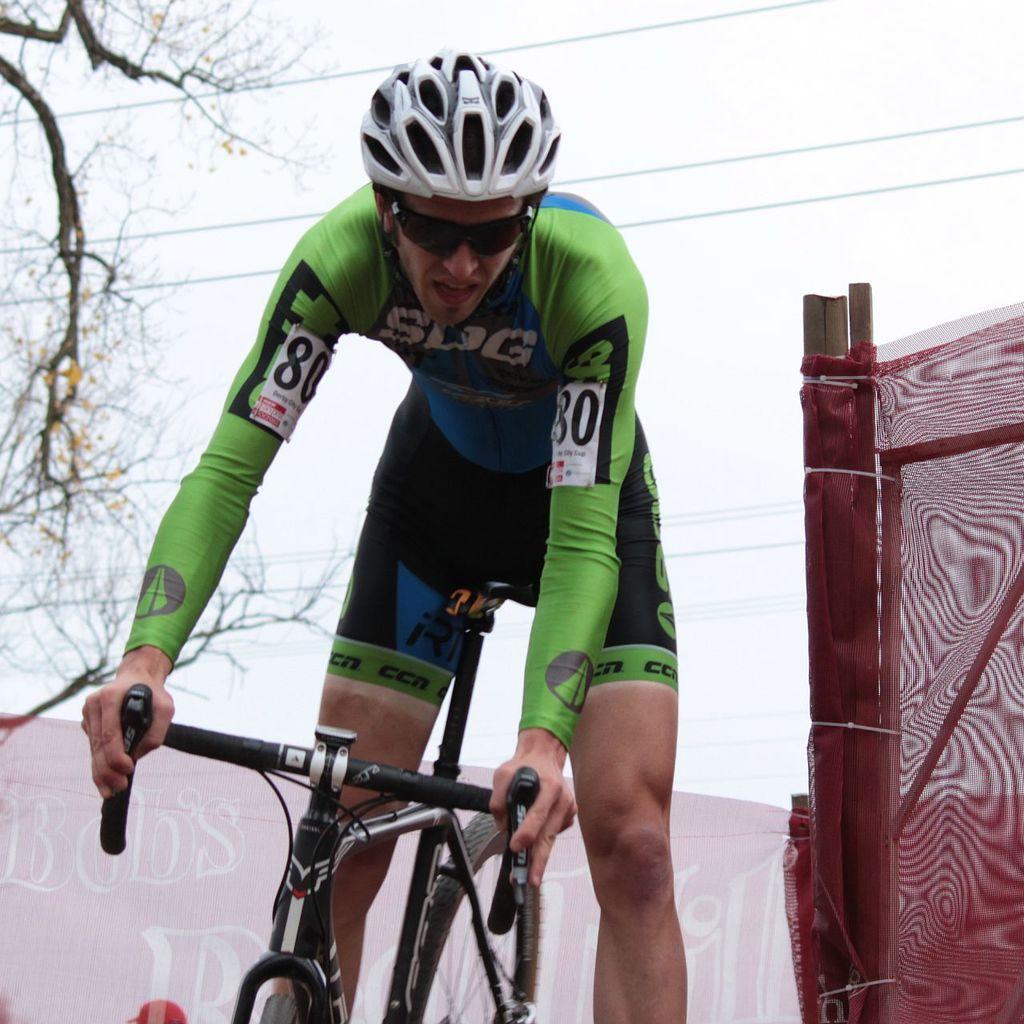Please provide a concise description of this image. There is a man who is sitting on a bicycle holding the handle of a cycle. He is wearing a helmet and a jersey with a number on it. In the background we can see a tree and the sky and wires. On the right side corner we can see a cloth which is attached to stick. 